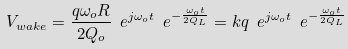<formula> <loc_0><loc_0><loc_500><loc_500>V _ { w a k e } = { \frac { q \omega _ { o } R } { 2 Q _ { o } } } \ e ^ { j \omega _ { o } t } \ e ^ { - { \frac { \omega _ { o } t } { 2 Q _ { L } } } } = k q \ e ^ { j \omega _ { o } t } \ e ^ { - { \frac { \omega _ { o } t } { 2 Q _ { L } } } }</formula> 